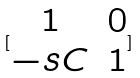<formula> <loc_0><loc_0><loc_500><loc_500>[ \begin{matrix} 1 & 0 \\ - s C & 1 \end{matrix} ]</formula> 